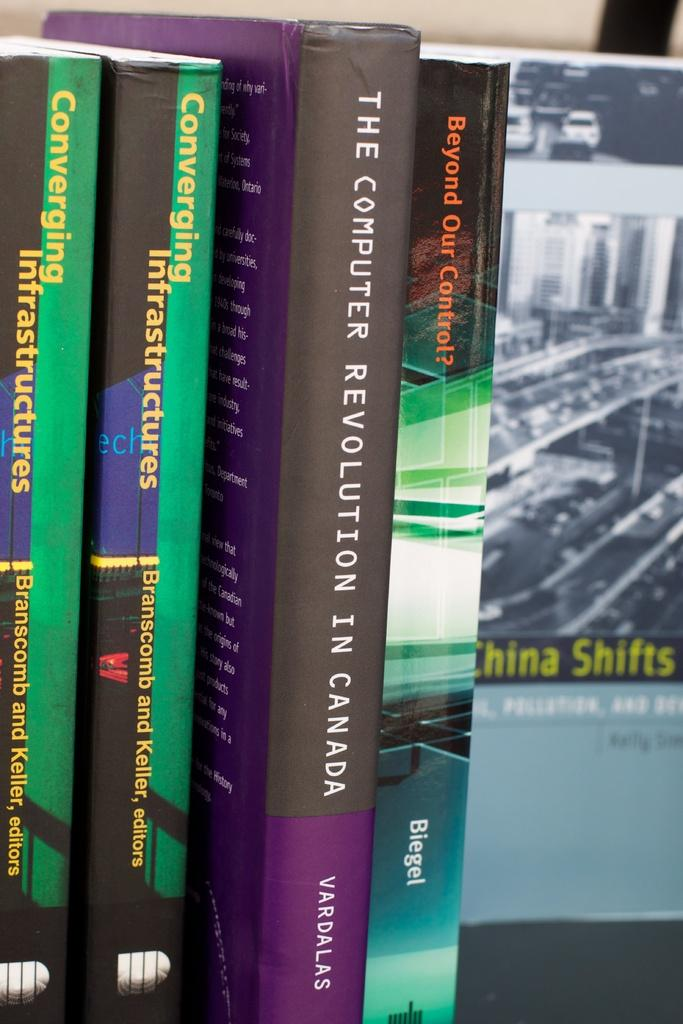<image>
Create a compact narrative representing the image presented. "The Computer Revolutions in Canada" is the name printed on the spine of this book. 